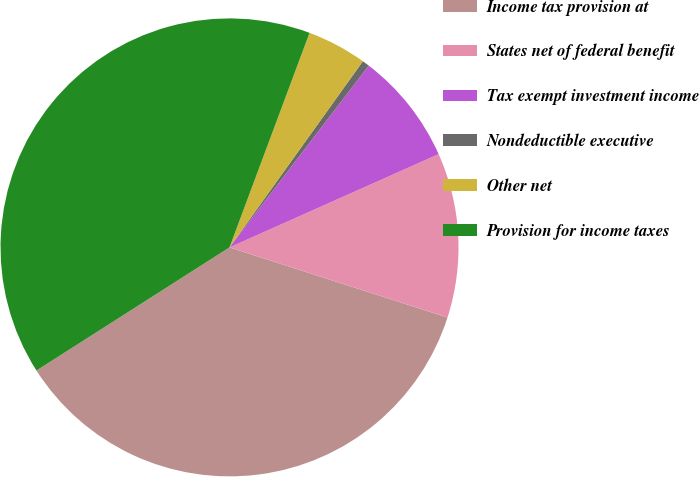Convert chart to OTSL. <chart><loc_0><loc_0><loc_500><loc_500><pie_chart><fcel>Income tax provision at<fcel>States net of federal benefit<fcel>Tax exempt investment income<fcel>Nondeductible executive<fcel>Other net<fcel>Provision for income taxes<nl><fcel>36.01%<fcel>11.63%<fcel>7.92%<fcel>0.51%<fcel>4.21%<fcel>39.72%<nl></chart> 